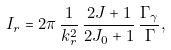Convert formula to latex. <formula><loc_0><loc_0><loc_500><loc_500>I _ { r } = 2 \pi \, \frac { 1 } { k ^ { 2 } _ { r } } \, \frac { 2 J + 1 } { 2 J _ { 0 } + 1 } \, \frac { \Gamma _ { \gamma } } { \Gamma } ,</formula> 